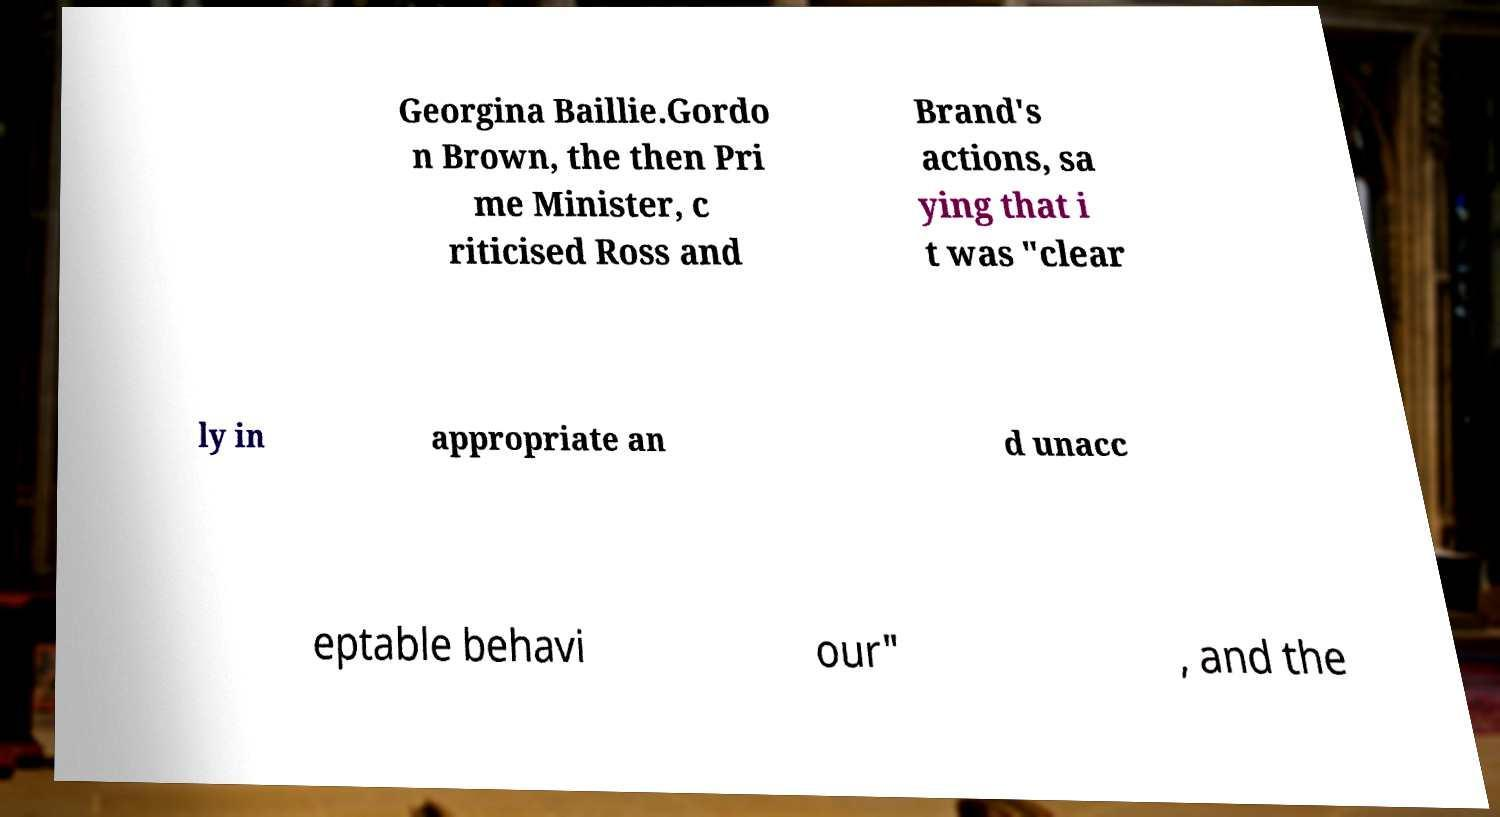Can you accurately transcribe the text from the provided image for me? Georgina Baillie.Gordo n Brown, the then Pri me Minister, c riticised Ross and Brand's actions, sa ying that i t was "clear ly in appropriate an d unacc eptable behavi our" , and the 